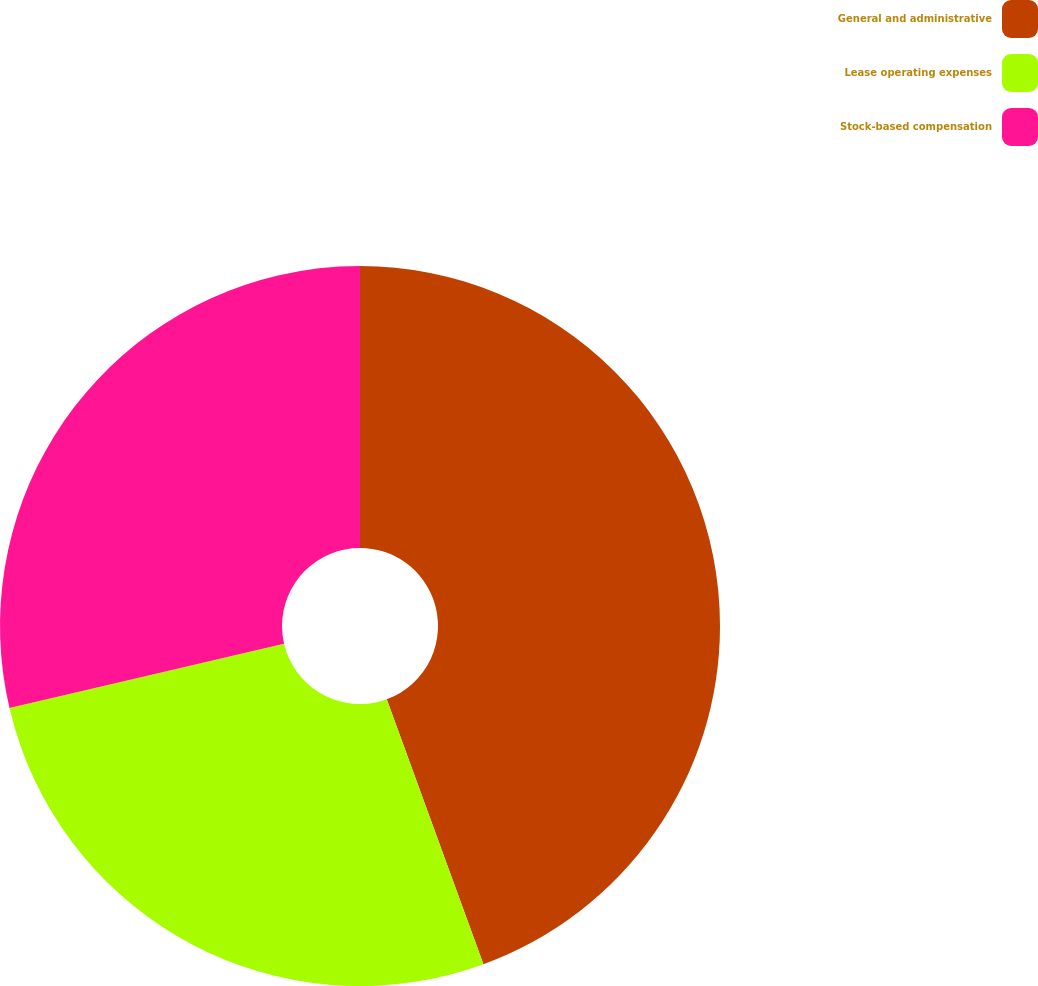Convert chart. <chart><loc_0><loc_0><loc_500><loc_500><pie_chart><fcel>General and administrative<fcel>Lease operating expenses<fcel>Stock-based compensation<nl><fcel>44.43%<fcel>26.91%<fcel>28.66%<nl></chart> 